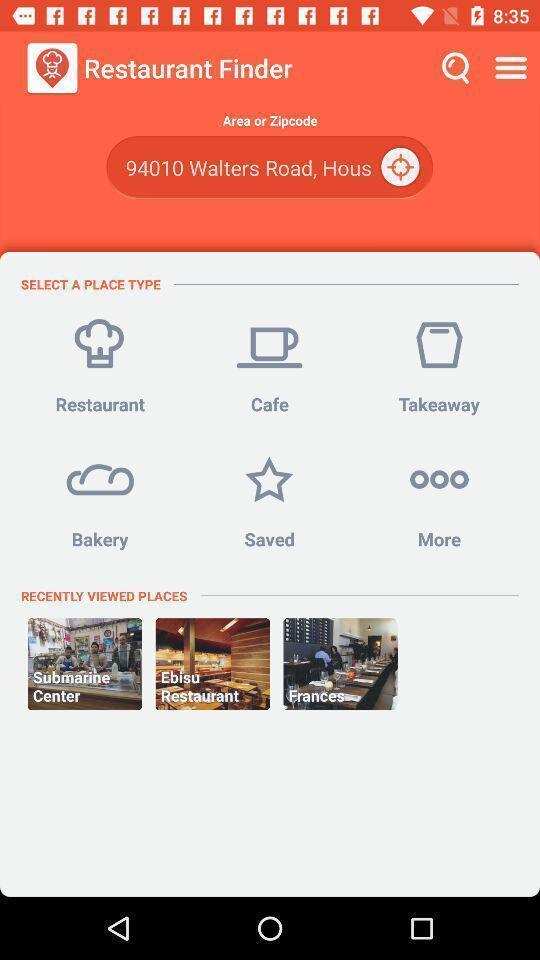Explain the elements present in this screenshot. Screen displaying the page of a food ordering app. 